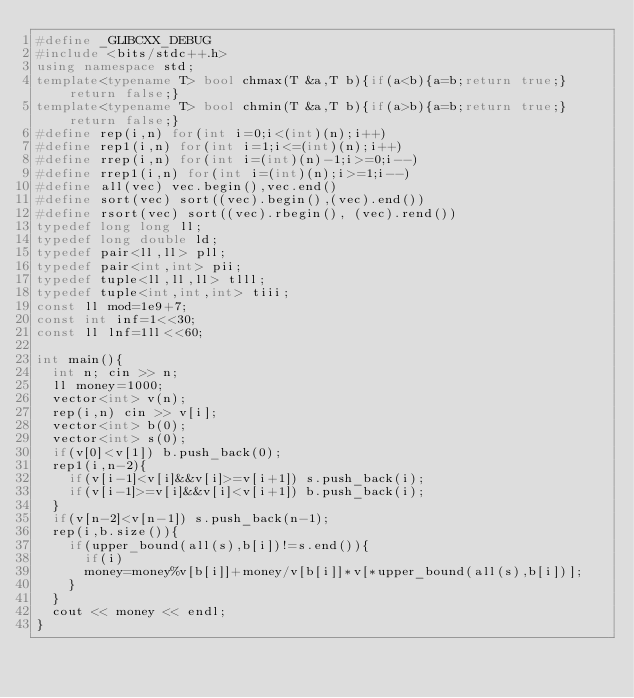<code> <loc_0><loc_0><loc_500><loc_500><_C++_>#define _GLIBCXX_DEBUG
#include <bits/stdc++.h>
using namespace std;
template<typename T> bool chmax(T &a,T b){if(a<b){a=b;return true;}return false;}
template<typename T> bool chmin(T &a,T b){if(a>b){a=b;return true;}return false;}
#define rep(i,n) for(int i=0;i<(int)(n);i++)
#define rep1(i,n) for(int i=1;i<=(int)(n);i++)
#define rrep(i,n) for(int i=(int)(n)-1;i>=0;i--)
#define rrep1(i,n) for(int i=(int)(n);i>=1;i--)
#define all(vec) vec.begin(),vec.end()
#define sort(vec) sort((vec).begin(),(vec).end())
#define rsort(vec) sort((vec).rbegin(), (vec).rend())
typedef long long ll;
typedef long double ld;
typedef pair<ll,ll> pll;
typedef pair<int,int> pii;
typedef tuple<ll,ll,ll> tlll;
typedef tuple<int,int,int> tiii;
const ll mod=1e9+7;
const int inf=1<<30;
const ll lnf=1ll<<60;

int main(){
  int n; cin >> n;
  ll money=1000;
  vector<int> v(n);
  rep(i,n) cin >> v[i];
  vector<int> b(0);
  vector<int> s(0);
  if(v[0]<v[1]) b.push_back(0);
  rep1(i,n-2){
    if(v[i-1]<v[i]&&v[i]>=v[i+1]) s.push_back(i);
    if(v[i-1]>=v[i]&&v[i]<v[i+1]) b.push_back(i);
  }
  if(v[n-2]<v[n-1]) s.push_back(n-1);
  rep(i,b.size()){
    if(upper_bound(all(s),b[i])!=s.end()){
      if(i)
      money=money%v[b[i]]+money/v[b[i]]*v[*upper_bound(all(s),b[i])];
    }
  }
  cout << money << endl;
}</code> 